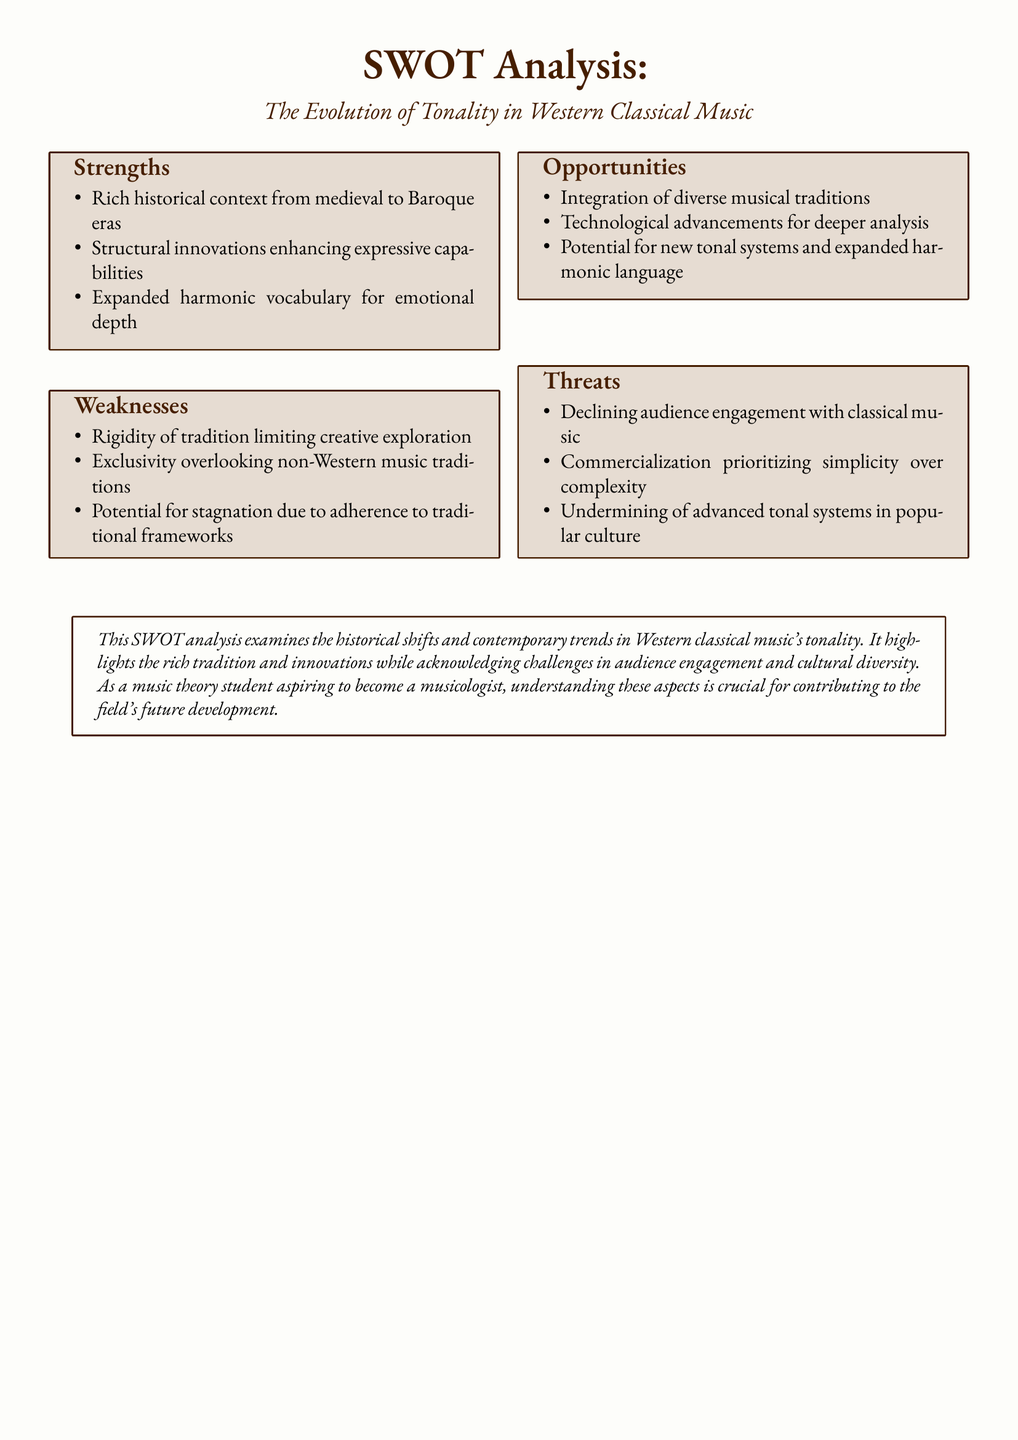What are the strengths of the tonality evolution? The strengths are listed in the SWOT analysis section, highlighting the rich historical context, structural innovations, and expanded harmonic vocabulary.
Answer: Rich historical context, structural innovations, expanded harmonic vocabulary What weaknesses are identified in the document? The weaknesses are listed in the SWOT analysis and include rigidity of tradition and potential for stagnation, among others.
Answer: Rigidity of tradition, exclusivity, stagnation What are the opportunities for tonality evolution? The opportunities are mentioned in the SWOT analysis section and include integration of diverse musical traditions and technological advancements.
Answer: Integration of diverse musical traditions, technological advancements What threats are discussed in the document? The threats mentioned include declining audience engagement and commercialization, as identified in the SWOT analysis.
Answer: Declining audience engagement, commercialization, undermining advanced tonal systems What does the SWOT analysis focus on? The SWOT analysis focuses on the historical shifts and contemporary trends in Western classical music's tonality.
Answer: Historical shifts and contemporary trends How many sections are there in the SWOT analysis? The SWOT analysis contains four sections: strengths, weaknesses, opportunities, and threats.
Answer: Four sections What is the color used for the box background in the SWOT analysis? The box background color in the SWOT analysis is described in the document.
Answer: RGB(230,220,210) What is the purpose of the SWOT analysis in the context of musicology? The document states that the analysis aims to contribute to the future development of the field.
Answer: Contributing to the field's future development 